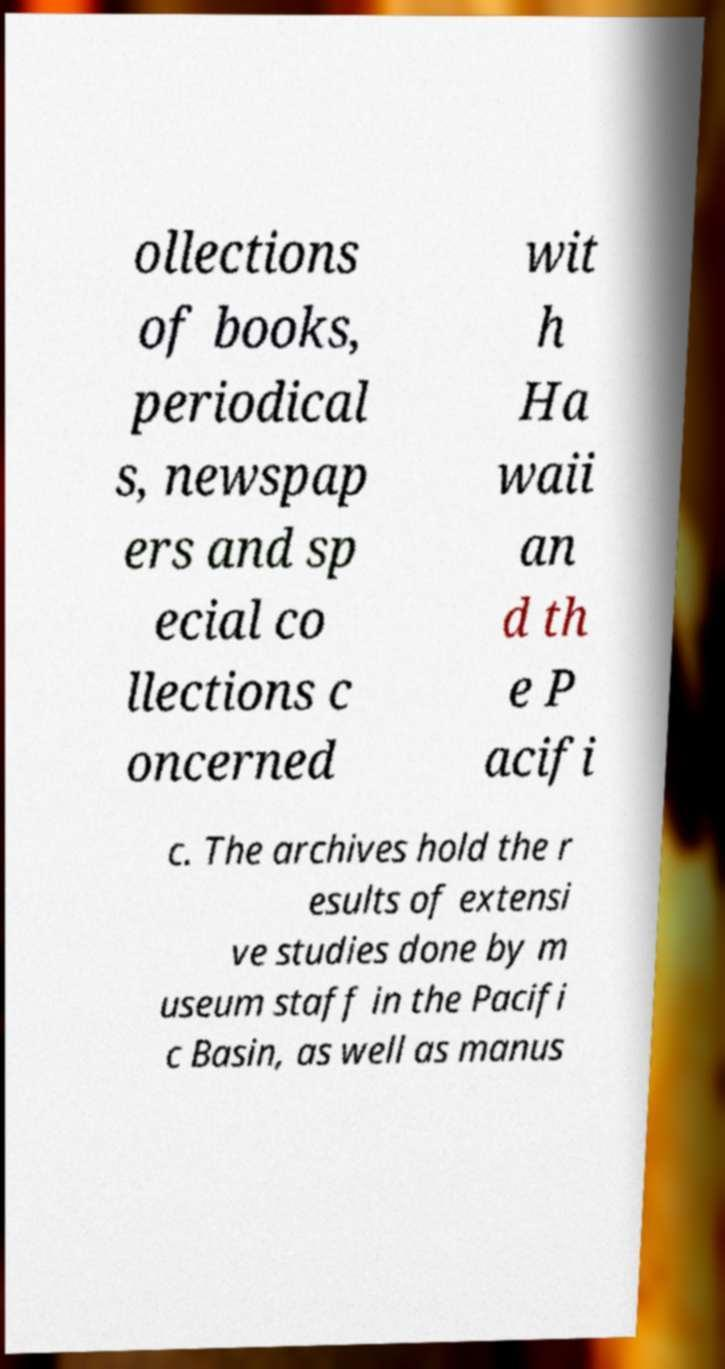Please read and relay the text visible in this image. What does it say? ollections of books, periodical s, newspap ers and sp ecial co llections c oncerned wit h Ha waii an d th e P acifi c. The archives hold the r esults of extensi ve studies done by m useum staff in the Pacifi c Basin, as well as manus 